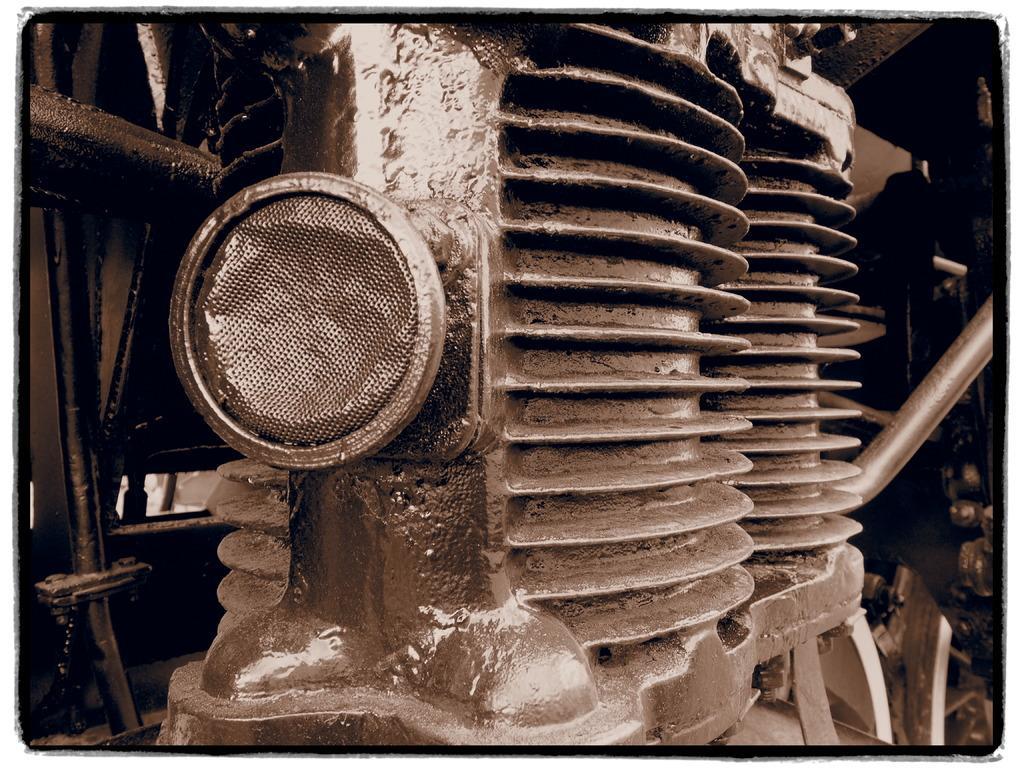Can you describe this image briefly? In this image I can see the machine which is in grey color. 